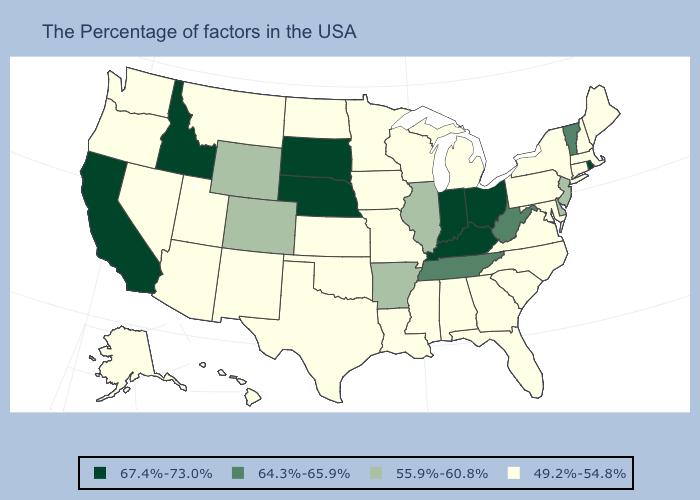What is the lowest value in the USA?
Be succinct. 49.2%-54.8%. Which states have the lowest value in the West?
Quick response, please. New Mexico, Utah, Montana, Arizona, Nevada, Washington, Oregon, Alaska, Hawaii. Does New York have the lowest value in the Northeast?
Short answer required. Yes. What is the lowest value in states that border Wyoming?
Concise answer only. 49.2%-54.8%. What is the value of Mississippi?
Quick response, please. 49.2%-54.8%. What is the value of Montana?
Write a very short answer. 49.2%-54.8%. Which states have the highest value in the USA?
Be succinct. Rhode Island, Ohio, Kentucky, Indiana, Nebraska, South Dakota, Idaho, California. Does the map have missing data?
Quick response, please. No. What is the value of Washington?
Quick response, please. 49.2%-54.8%. Does North Carolina have the same value as Nebraska?
Give a very brief answer. No. What is the lowest value in the USA?
Short answer required. 49.2%-54.8%. What is the value of Illinois?
Short answer required. 55.9%-60.8%. What is the value of Iowa?
Concise answer only. 49.2%-54.8%. What is the value of Nebraska?
Write a very short answer. 67.4%-73.0%. What is the highest value in states that border South Carolina?
Concise answer only. 49.2%-54.8%. 